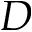Convert formula to latex. <formula><loc_0><loc_0><loc_500><loc_500>D</formula> 